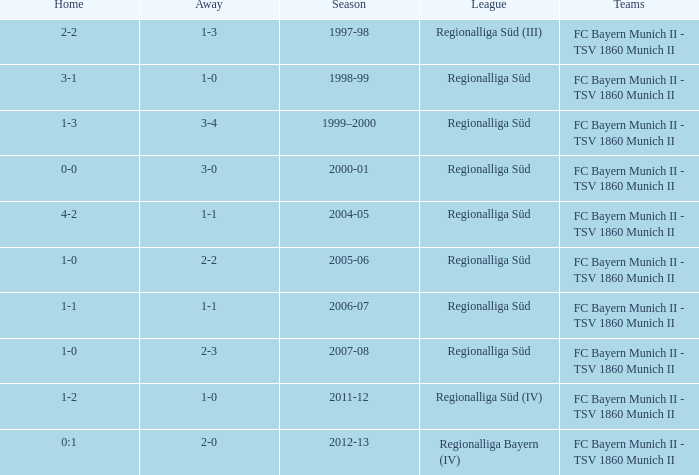Parse the full table. {'header': ['Home', 'Away', 'Season', 'League', 'Teams'], 'rows': [['2-2', '1-3', '1997-98', 'Regionalliga Süd (III)', 'FC Bayern Munich II - TSV 1860 Munich II'], ['3-1', '1-0', '1998-99', 'Regionalliga Süd', 'FC Bayern Munich II - TSV 1860 Munich II'], ['1-3', '3-4', '1999–2000', 'Regionalliga Süd', 'FC Bayern Munich II - TSV 1860 Munich II'], ['0-0', '3-0', '2000-01', 'Regionalliga Süd', 'FC Bayern Munich II - TSV 1860 Munich II'], ['4-2', '1-1', '2004-05', 'Regionalliga Süd', 'FC Bayern Munich II - TSV 1860 Munich II'], ['1-0', '2-2', '2005-06', 'Regionalliga Süd', 'FC Bayern Munich II - TSV 1860 Munich II'], ['1-1', '1-1', '2006-07', 'Regionalliga Süd', 'FC Bayern Munich II - TSV 1860 Munich II'], ['1-0', '2-3', '2007-08', 'Regionalliga Süd', 'FC Bayern Munich II - TSV 1860 Munich II'], ['1-2', '1-0', '2011-12', 'Regionalliga Süd (IV)', 'FC Bayern Munich II - TSV 1860 Munich II'], ['0:1', '2-0', '2012-13', 'Regionalliga Bayern (IV)', 'FC Bayern Munich II - TSV 1860 Munich II']]} What season has a regionalliga süd league, a 1-0 home, and an away of 2-3? 2007-08. 